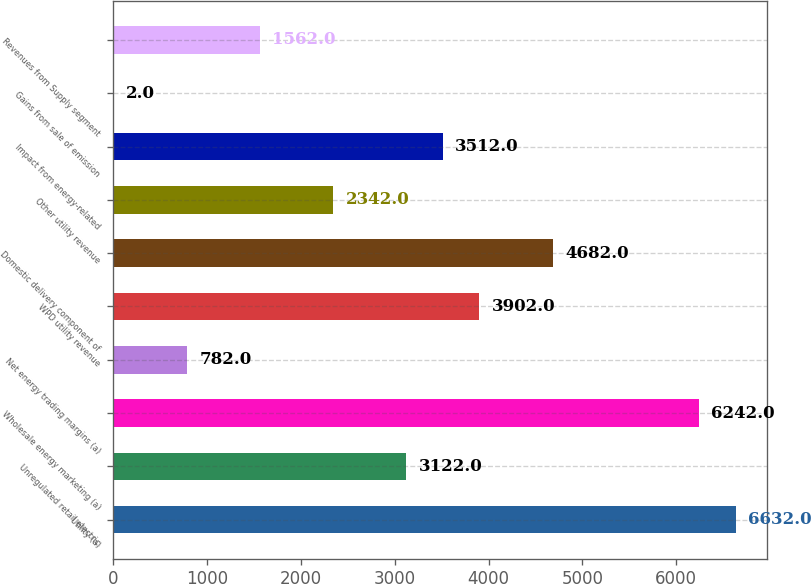<chart> <loc_0><loc_0><loc_500><loc_500><bar_chart><fcel>Utility (a)<fcel>Unregulated retail electric<fcel>Wholesale energy marketing (a)<fcel>Net energy trading margins (a)<fcel>WPD utility revenue<fcel>Domestic delivery component of<fcel>Other utility revenue<fcel>Impact from energy-related<fcel>Gains from sale of emission<fcel>Revenues from Supply segment<nl><fcel>6632<fcel>3122<fcel>6242<fcel>782<fcel>3902<fcel>4682<fcel>2342<fcel>3512<fcel>2<fcel>1562<nl></chart> 